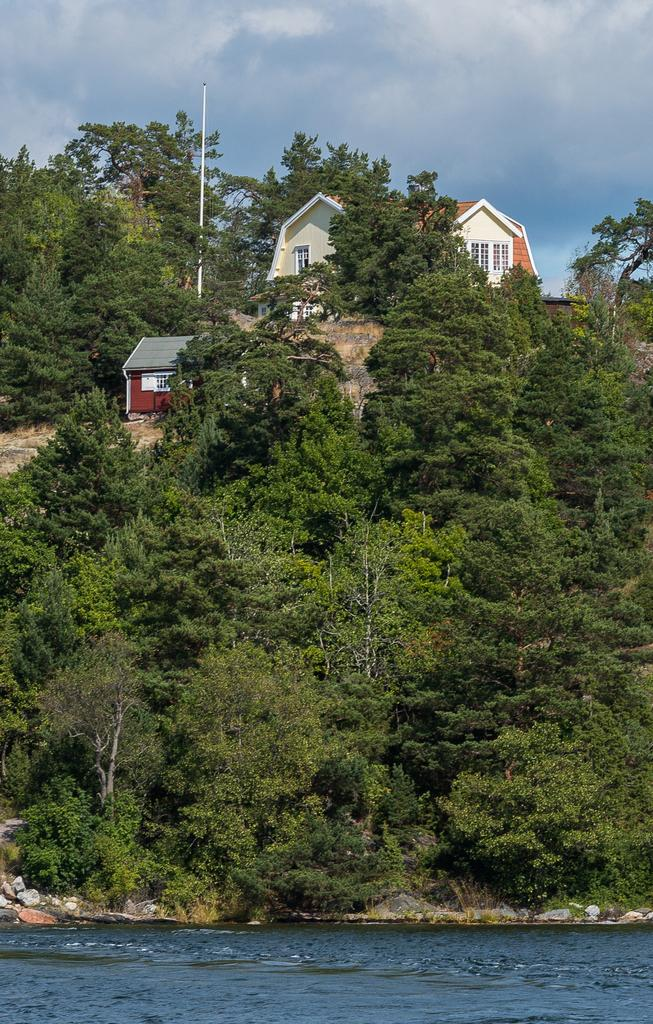What type of vegetation can be seen in the image? There are trees in the image. What type of structures are present in the image? There are sheds in the image. What is the tall, vertical object in the image? There is a pole in the image. What can be seen at the bottom of the image? There is water visible at the bottom of the image. What is visible in the sky at the top of the image? There are clouds in the sky at the top of the image. What type of butter can be seen on the trees in the image? There is no butter present in the image. 